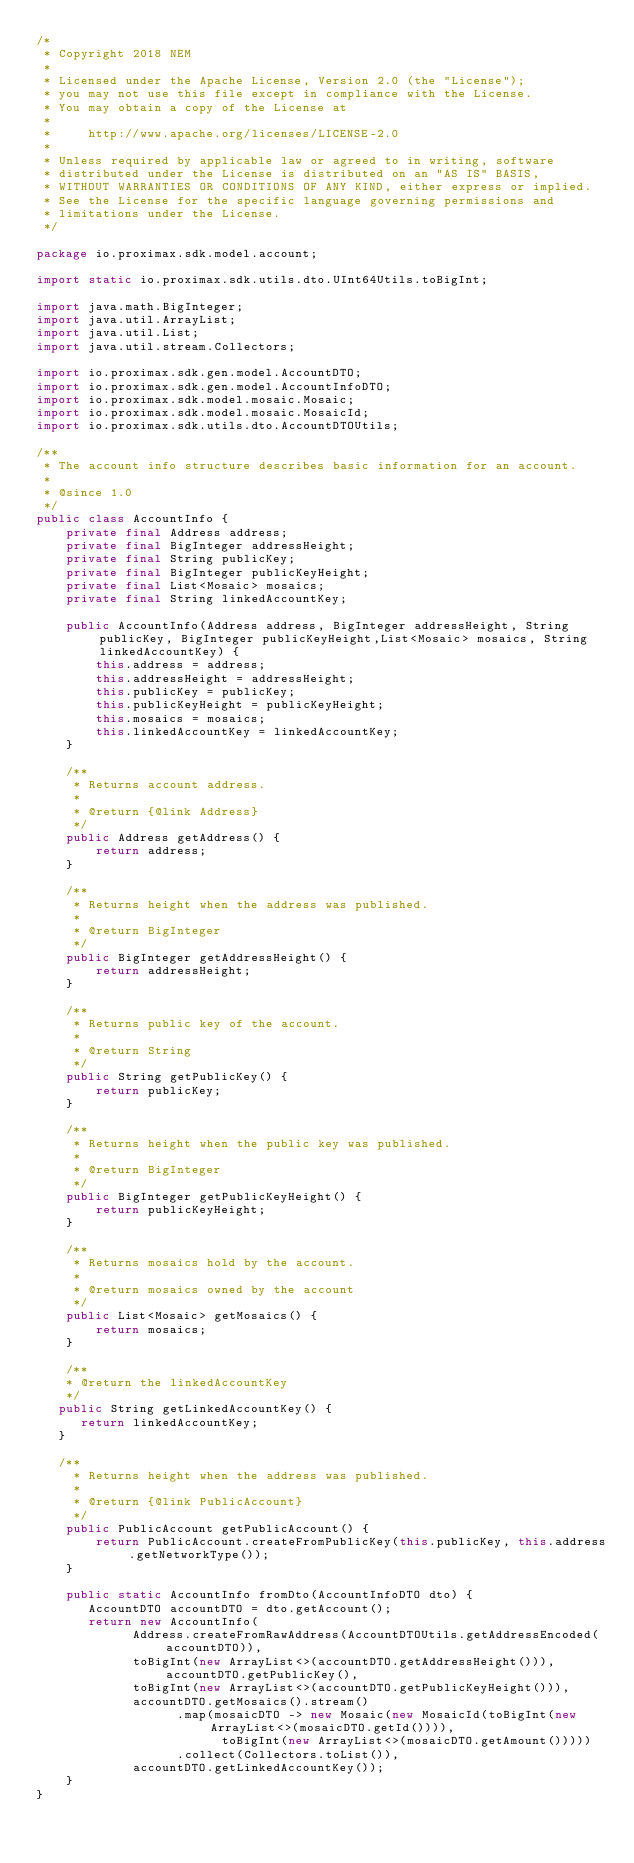<code> <loc_0><loc_0><loc_500><loc_500><_Java_>/*
 * Copyright 2018 NEM
 *
 * Licensed under the Apache License, Version 2.0 (the "License");
 * you may not use this file except in compliance with the License.
 * You may obtain a copy of the License at
 *
 *     http://www.apache.org/licenses/LICENSE-2.0
 *
 * Unless required by applicable law or agreed to in writing, software
 * distributed under the License is distributed on an "AS IS" BASIS,
 * WITHOUT WARRANTIES OR CONDITIONS OF ANY KIND, either express or implied.
 * See the License for the specific language governing permissions and
 * limitations under the License.
 */

package io.proximax.sdk.model.account;

import static io.proximax.sdk.utils.dto.UInt64Utils.toBigInt;

import java.math.BigInteger;
import java.util.ArrayList;
import java.util.List;
import java.util.stream.Collectors;

import io.proximax.sdk.gen.model.AccountDTO;
import io.proximax.sdk.gen.model.AccountInfoDTO;
import io.proximax.sdk.model.mosaic.Mosaic;
import io.proximax.sdk.model.mosaic.MosaicId;
import io.proximax.sdk.utils.dto.AccountDTOUtils;

/**
 * The account info structure describes basic information for an account.
 *
 * @since 1.0
 */
public class AccountInfo {
    private final Address address;
    private final BigInteger addressHeight;
    private final String publicKey;
    private final BigInteger publicKeyHeight;
    private final List<Mosaic> mosaics;
    private final String linkedAccountKey;

    public AccountInfo(Address address, BigInteger addressHeight, String publicKey, BigInteger publicKeyHeight,List<Mosaic> mosaics, String linkedAccountKey) {
        this.address = address;
        this.addressHeight = addressHeight;
        this.publicKey = publicKey;
        this.publicKeyHeight = publicKeyHeight;
        this.mosaics = mosaics;
        this.linkedAccountKey = linkedAccountKey;
    }

    /**
     * Returns account address.
     *
     * @return {@link Address}
     */
    public Address getAddress() {
        return address;
    }

    /**
     * Returns height when the address was published.
     *
     * @return BigInteger
     */
    public BigInteger getAddressHeight() {
        return addressHeight;
    }

    /**
     * Returns public key of the account.
     *
     * @return String
     */
    public String getPublicKey() {
        return publicKey;
    }

    /**
     * Returns height when the public key was published.
     *
     * @return BigInteger
     */
    public BigInteger getPublicKeyHeight() {
        return publicKeyHeight;
    }

    /**
     * Returns mosaics hold by the account.
     *
     * @return mosaics owned by the account
     */
    public List<Mosaic> getMosaics() {
        return mosaics;
    }

    /**
    * @return the linkedAccountKey
    */
   public String getLinkedAccountKey() {
      return linkedAccountKey;
   }

   /**
     * Returns height when the address was published.
     *
     * @return {@link PublicAccount}
     */
    public PublicAccount getPublicAccount() {
        return PublicAccount.createFromPublicKey(this.publicKey, this.address.getNetworkType());
    }
    
    public static AccountInfo fromDto(AccountInfoDTO dto) {
       AccountDTO accountDTO = dto.getAccount();
       return new AccountInfo(
             Address.createFromRawAddress(AccountDTOUtils.getAddressEncoded(accountDTO)),
             toBigInt(new ArrayList<>(accountDTO.getAddressHeight())), accountDTO.getPublicKey(),
             toBigInt(new ArrayList<>(accountDTO.getPublicKeyHeight())),
             accountDTO.getMosaics().stream()
                   .map(mosaicDTO -> new Mosaic(new MosaicId(toBigInt(new ArrayList<>(mosaicDTO.getId()))),
                         toBigInt(new ArrayList<>(mosaicDTO.getAmount()))))
                   .collect(Collectors.toList()),
             accountDTO.getLinkedAccountKey());
    }
}
</code> 